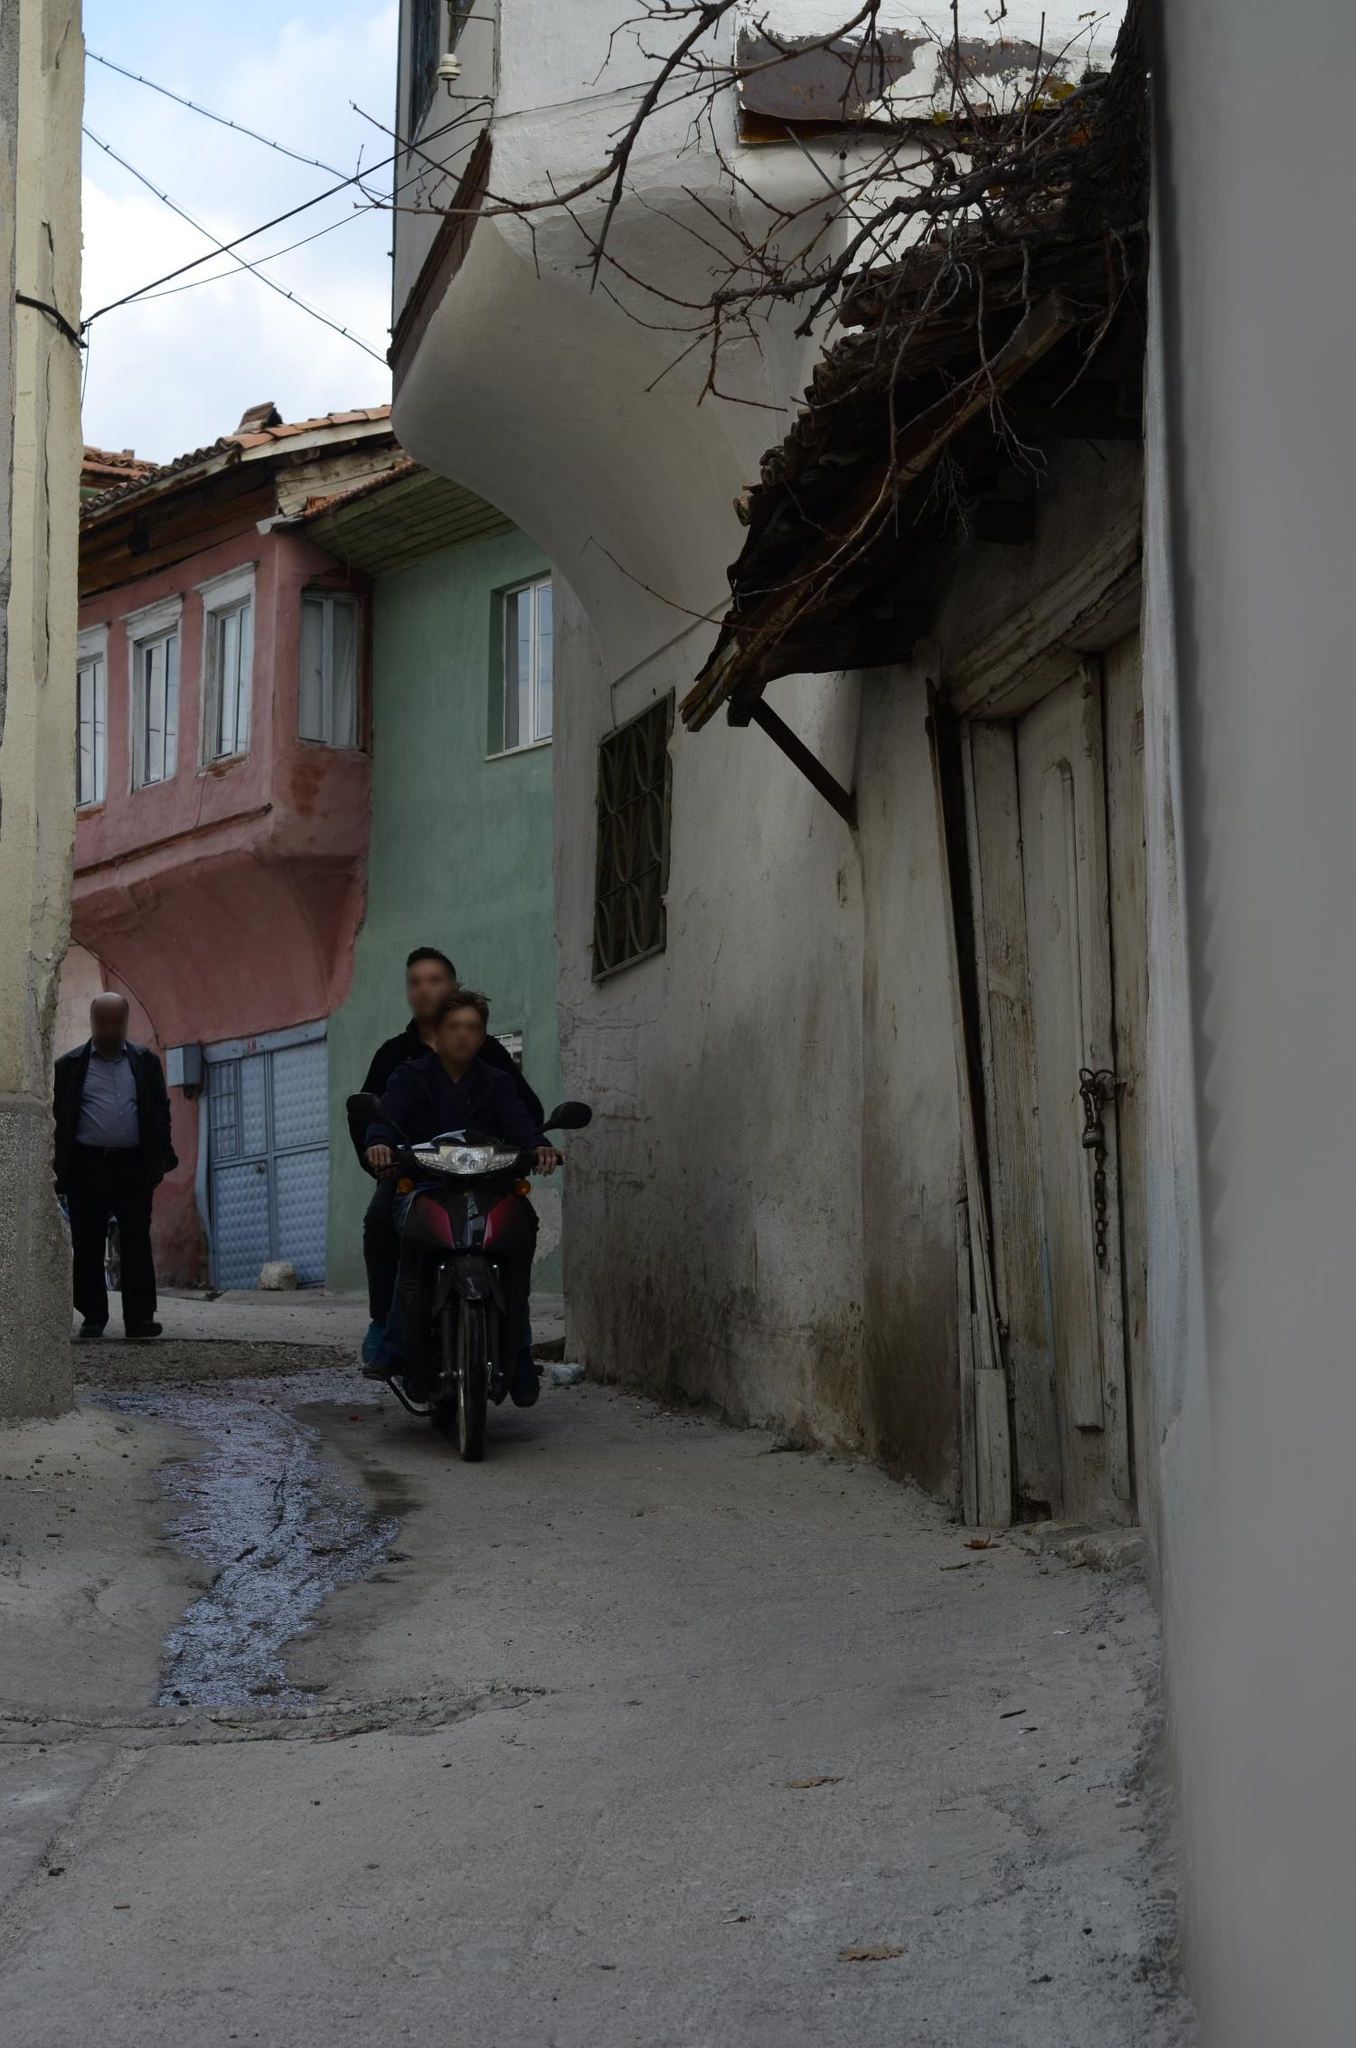Can you tell me more about the architectural styles visible in this image? The architecture in the image showcases a blend of traditional elements likely from the early to mid-20th century. The facades are adorned with features such as rustic wooden doors, small, ornate windows, and plastered walls in need of repair. The variety in window shapes and the presence of small balconies suggest a functional, modest approach to design, commonly seen in residential areas built before modern city planning. These styles reflect a practical adaptation to local conditions, possibly indicating a community with deep historical roots. 